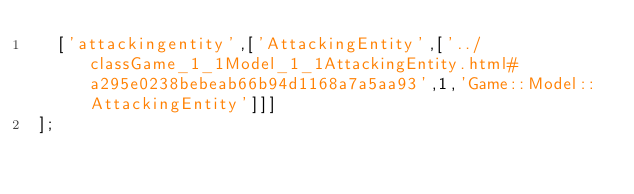Convert code to text. <code><loc_0><loc_0><loc_500><loc_500><_JavaScript_>  ['attackingentity',['AttackingEntity',['../classGame_1_1Model_1_1AttackingEntity.html#a295e0238bebeab66b94d1168a7a5aa93',1,'Game::Model::AttackingEntity']]]
];
</code> 